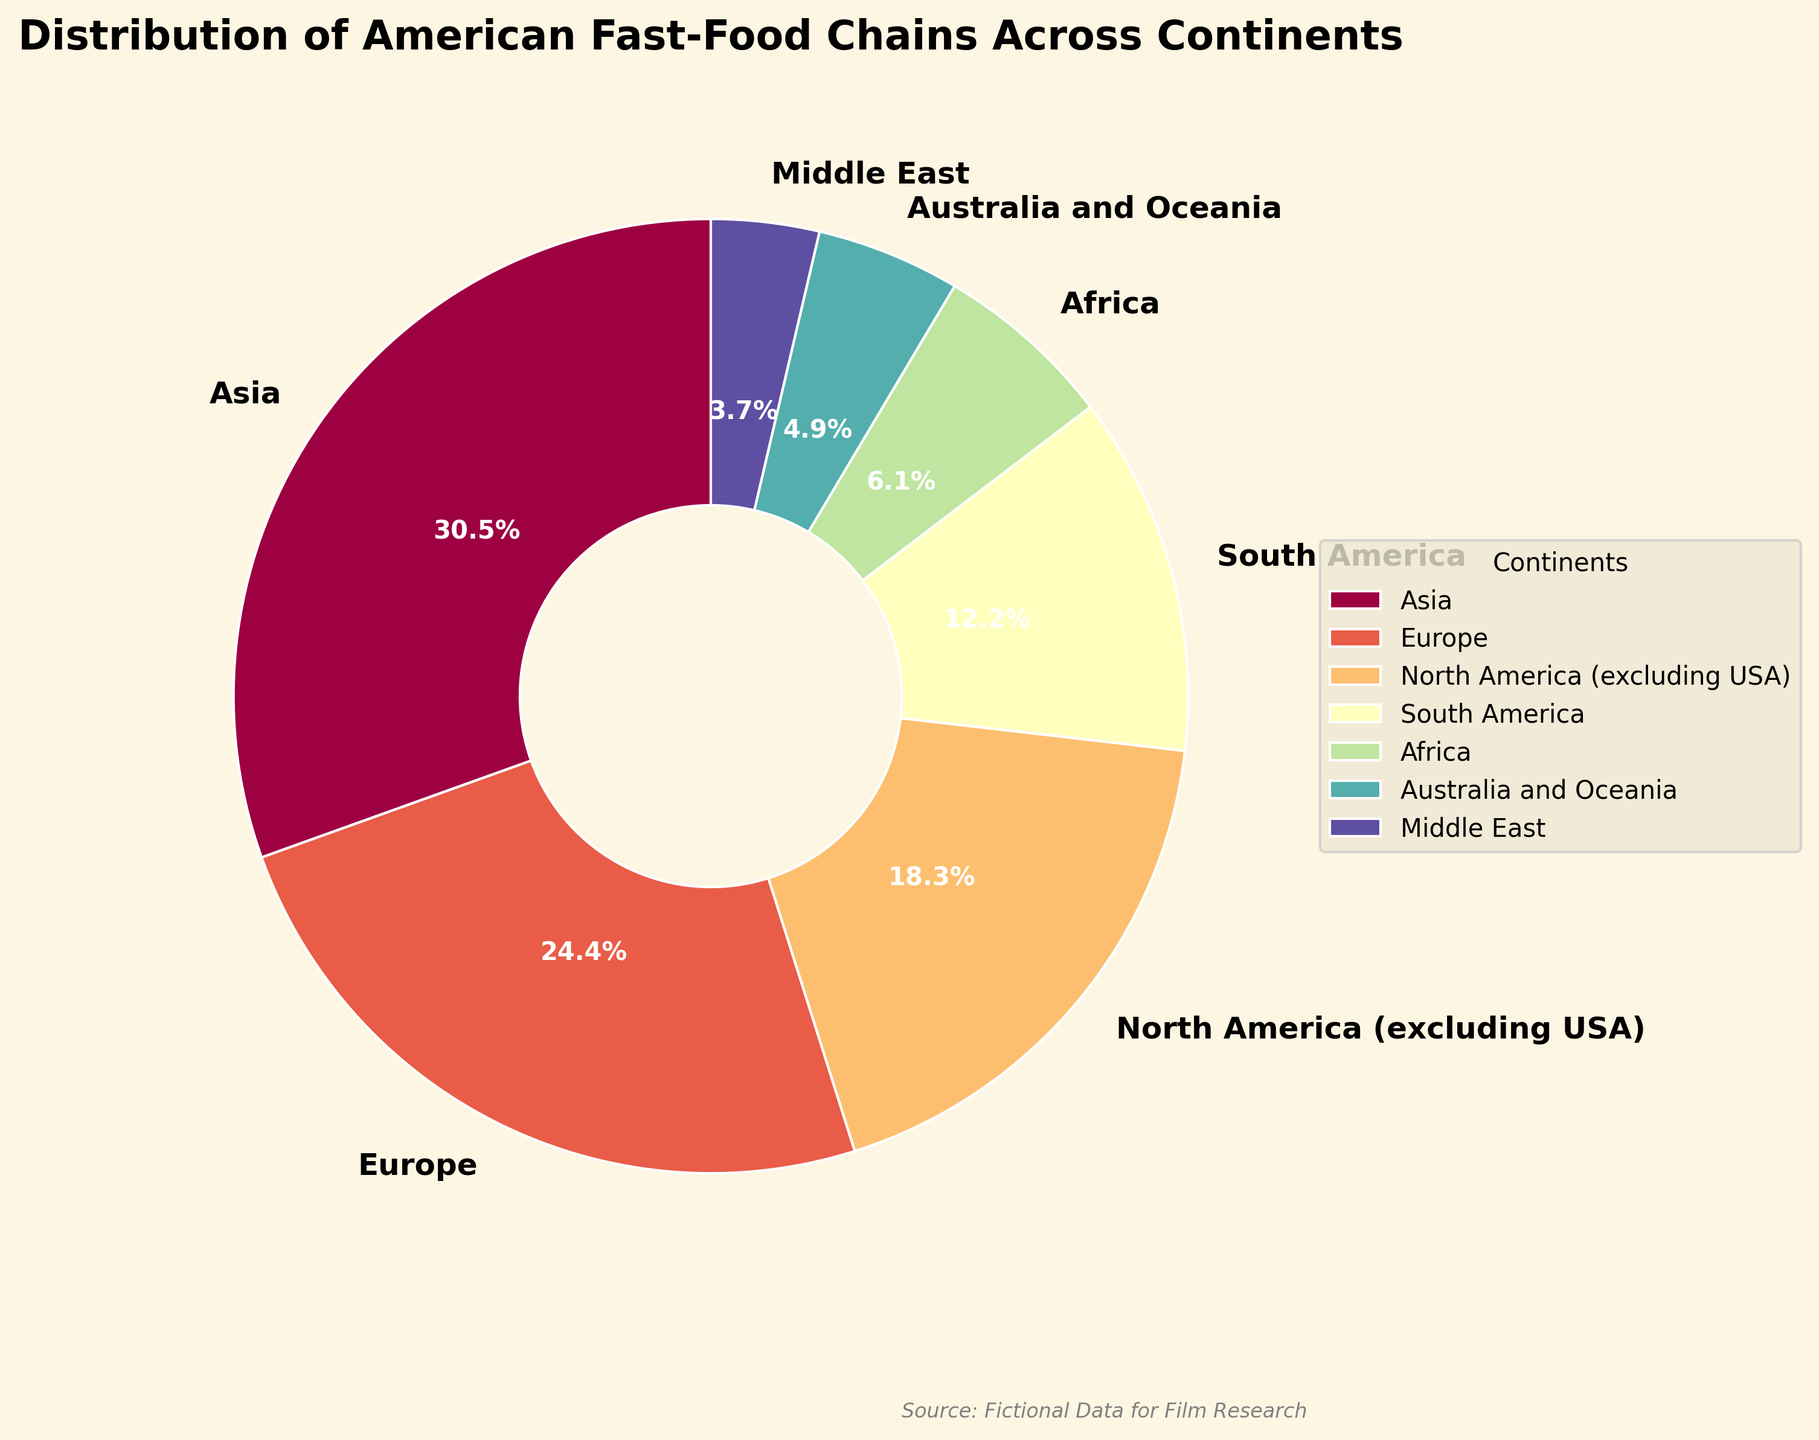What continent has the highest number of American fast-food chain locations? The pie chart shows the distribution, and the largest segment corresponds to Asia.
Answer: Asia What is the total percentage of American fast-food chain locations found in Europe and Africa combined? According to the figure, Europe has 20,000 locations and Africa has 5,000 locations. If Europe makes up 24.2% and Africa 6.1%, their combined percentage is 24.2% + 6.1% = 30.3%.
Answer: 30.3% Which continents have fewer than 5% of the total American fast-food chain locations? From the chart reading, only "Middle East" has 3% (smaller than 5%).
Answer: Middle East What is the difference in location numbers between North America (excluding the USA) and South America? North America (excluding the USA) has 15,000 locations, and South America has 10,000 locations, so the difference is 15,000 - 10,000 = 5,000.
Answer: 5,000 What is the average number of American fast-food chain locations across Africa, South America, and Australia and Oceania? Summing the locations for Africa (5,000), South America (10,000), and Australia and Oceania (4,000) gives 5,000 + 10,000 + 4,000 = 19,000. The average is 19,000 / 3 = 6,333.33.
Answer: 6,333.33 Is the percentage of American fast-food chains in North America (excluding the USA) greater than in South America? The chart shows North America (excluding the USA) with 15000 locations, and South America with 10000 locations. In percentages, North America (excluding the USA) is more than South America with 18.2% > 12.1%.
Answer: Yes How many continents have more than 10% of the total American fast-food chain locations? The chart segments bigger than 10% are Asia (30.3%) and Europe (24.2%), showing that there are 2 such continents.
Answer: 2 Which continent is represented by the darkest color in the pie chart? By looking at the colors, "Asia" is represented with the darkest color in the pie chart.
Answer: Asia What is the combined total of American fast-food chain locations in Asia, the Middle East, and Africa? The number of locations in Asia is 25,000, in the Middle East is 3,000, and in Africa is 5,000. Their combined total is 25,000 + 3,000 + 5,000 = 33,000.
Answer: 33,000 Which continent has the smallest number of American fast-food chain locations? By observation, Middle East has the smallest segment with 3,000 locations.
Answer: Middle East 